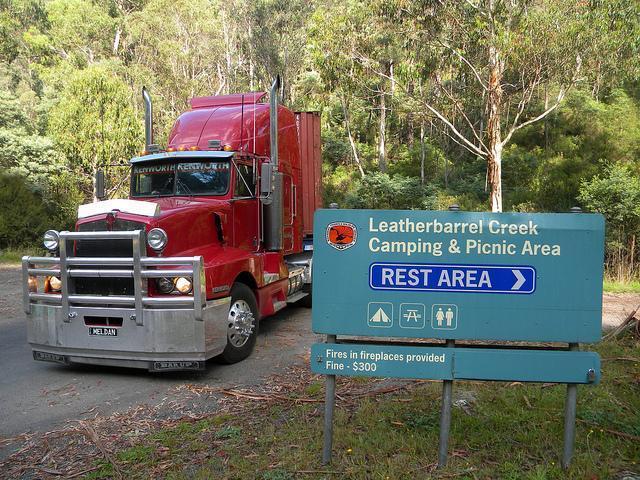How many people in the boat are wearing life jackets?
Give a very brief answer. 0. 